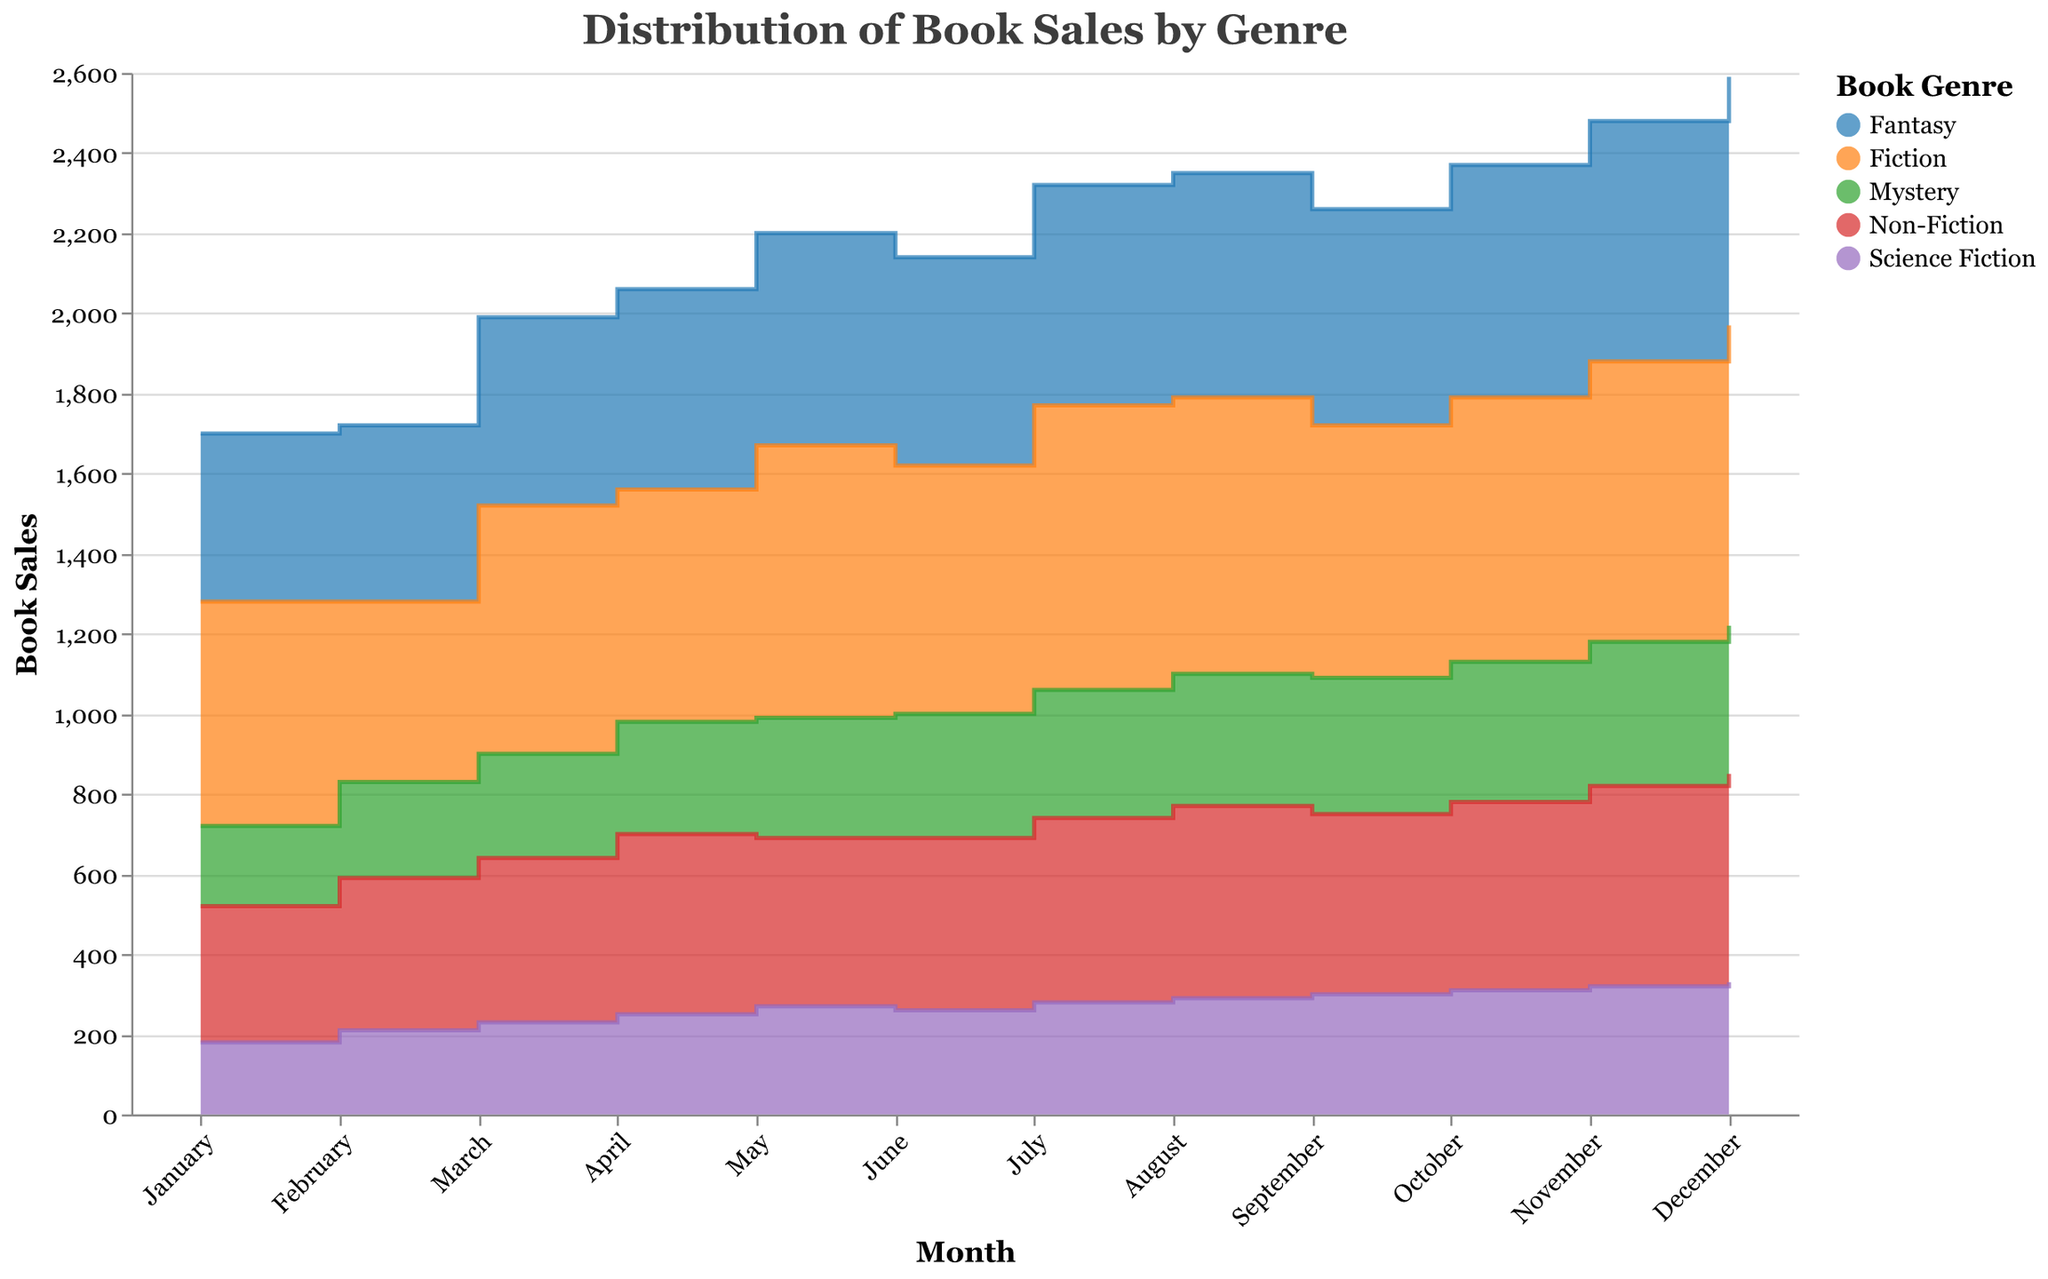What is the highest book sales recorded in Fiction throughout the year? By looking at the step area chart for Fiction, we can see that the highest point on the y-axis that represents book sales is reached in December with a value of 750.
Answer: 750 Which Genre had the highest book sales in November? Looking at the step area chart in November, Fiction is the genre that reaches the highest point on the y-axis for book sales, which is 700.
Answer: Fiction How do the sales of Mystery books in January compare to those in December? In January, the sales of Mystery books are represented by a point at 200 on the y-axis. In December, the sales are represented by a point at 370 on the y-axis. Thus, December sales are higher than January sales.
Answer: December sales are higher What's the overall trend of Non-Fiction book sales from January to December? Observing the step area chart for Non-Fiction, the book sales gradually increase from January (340) to December (520), indicating an upward trend over the months.
Answer: Upward trend Among the genres presented, which one shows the most consistent monthly sales? By examining the step area chart, Mystery shows the most consistent monthly sales. The sales figures gradually increase each month in small increments from 200 in January to 370 in December.
Answer: Mystery What is the total sales of Science Fiction books in the first quarter (January to March)? Summing up the sales of Science Fiction books for January, February, and March: 180 + 210 + 230 = 620.
Answer: 620 Which two months have the smallest difference in Fiction book sales? Looking at the step area chart, May (680) and July (710) have the smallest difference of 30 in Fiction book sales when comparing the adjacent months.
Answer: May and July How do the sales of Fantasy books in the second quarter (April to June) compare to those in the first quarter (January to March)? The total sales for the first quarter (January to March) are 420 + 440 + 470 = 1330. For the second quarter (April to June), it's 500 + 530 + 520 = 1550. Thus, the second quarter has higher sales.
Answer: Second quarter has higher sales Which genre has the steepest increase in book sales in any single month, and in which month? The steepest increase can be observed in Fiction, from February (450) to March (620), marking a jump of 170 sales in a single month.
Answer: Fiction in March Compare the book sales trend of Fantasy and Science Fiction genres. The Fantasy genre shows an overall upward trend with occasional small dips, ending significantly higher in December (620) than January (420). Conversely, Science Fiction also trends upward but starts lower and ends lower (330 in December, starting at 180 in January). Thus, Fantasy generally has higher growth.
Answer: Fantasy has higher growth 